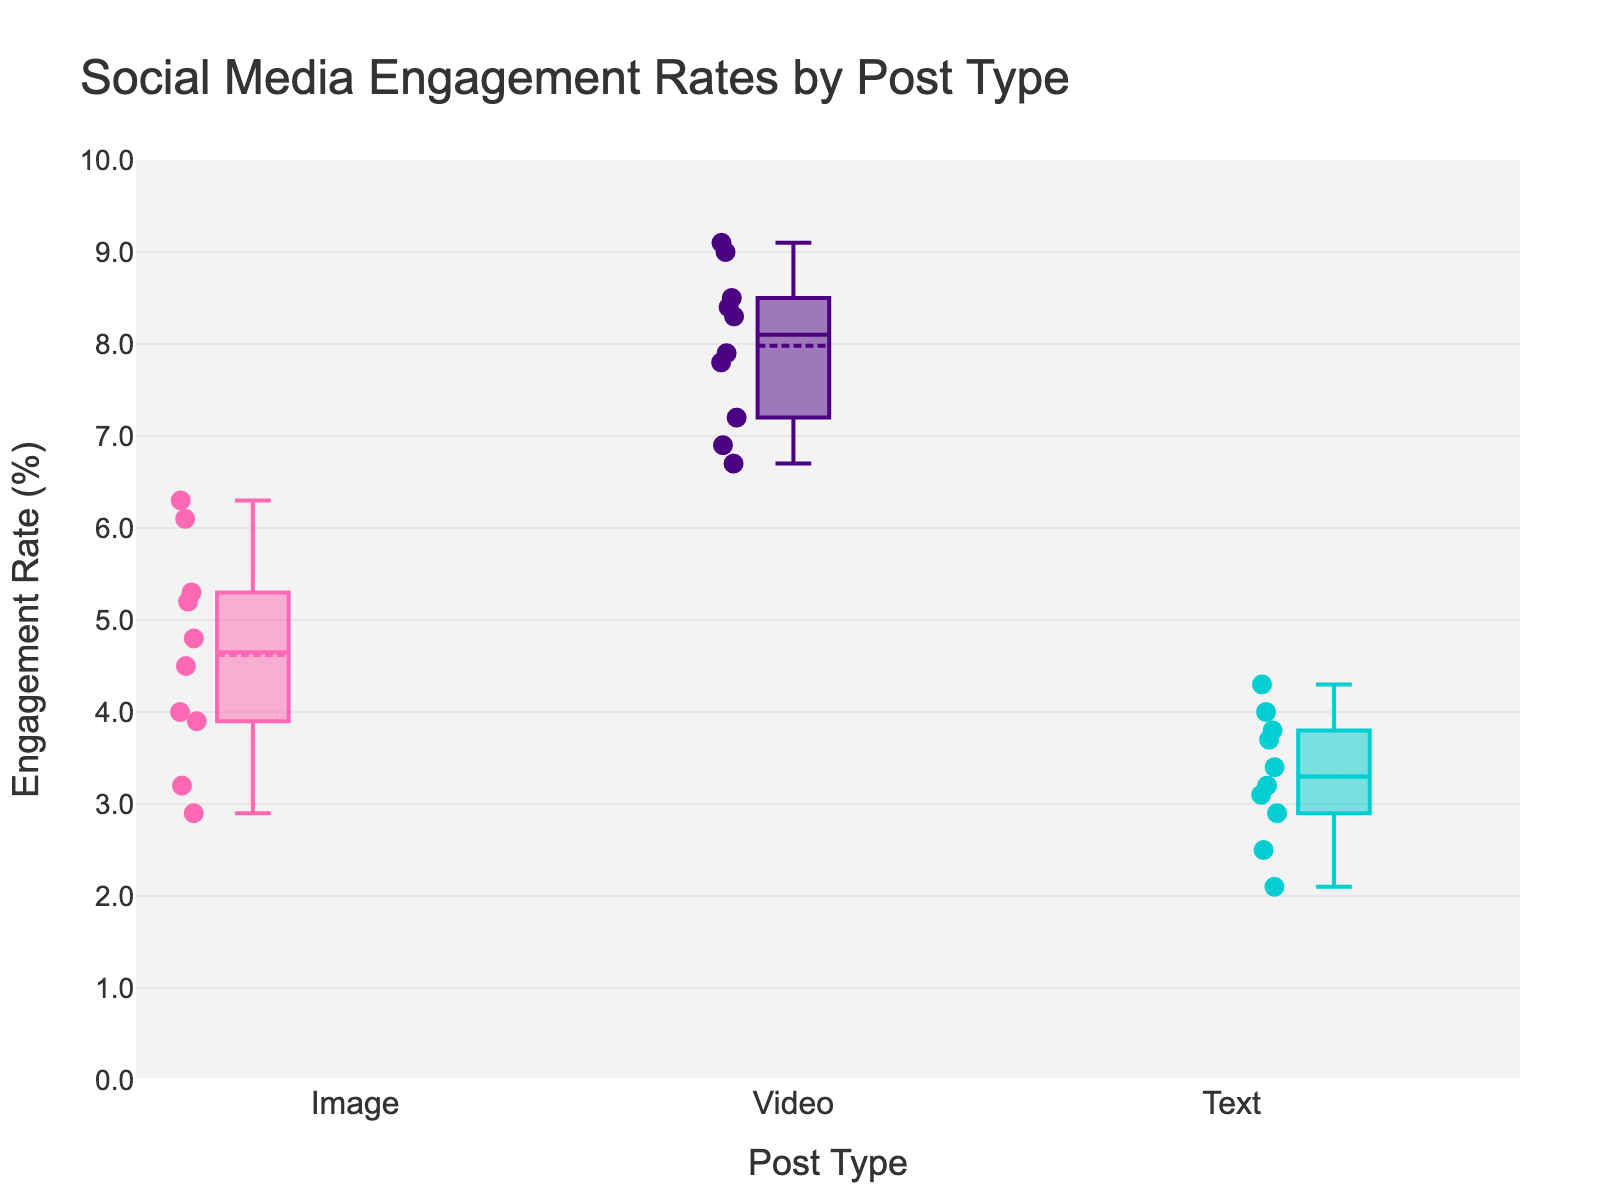what are the types of posts analyzed in this figure? The figure categorizes the data into three types of posts: Image, Video, and Text, which are indicated along the x-axis.
Answer: Image, Video, Text What is the maximum engagement rate for image posts? The highest point within the box plot for Image posts is observed at 6.3%.
Answer: 6.3% Which type of post has the highest average engagement rate? By comparing the marking point inside each box (which represents the mean), Video posts have the highest average engagement rate.
Answer: Video What's the median engagement rate for text posts? The median engagement rate for Text posts is represented by the line inside the box for Text, which is around 3.4%.
Answer: 3.4% How do the outliers appear in this plot, and which post types have them? The outliers appear as individual scatter points significantly outside the whiskers. Based on the provided plot, there are no apparent outliers, as all points are within the expected range.
Answer: None Which type of post shows the widest distribution of engagement rates? The Video post type has the widest range of engagement rates, as indicated by the longer whiskers and more spread-out data points compared to Image and Text posts.
Answer: Video What is the range of engagement rates for text posts? The range is determined by the highest value minus the lowest value within the Text posts. From the plot, the highest is 4.3% and the lowest is 2.1%, so the range is 4.3% - 2.1%.
Answer: 2.2% Compare the median engagement rates of image and video posts. The median for Image posts is around 4.5%, whereas for Video posts it is around 8.3%, indicating that Video posts have a significantly higher median engagement rate.
Answer: Video posts have higher median How does the average engagement rate for image posts compare to the text posts? The mean engagement rate represented by the marker inside the box is higher for Image posts (around 4.5%) compared to Text posts (around 3.1%).
Answer: Image posts have higher average What does the box mean indicate in the context of this plot? The box itself represents the interquartile range (IQR), showing the middle 50% of the data. The line inside the box indicates the median, while the points inside the box indicate the mean.
Answer: Interquartile range, median, and mean 